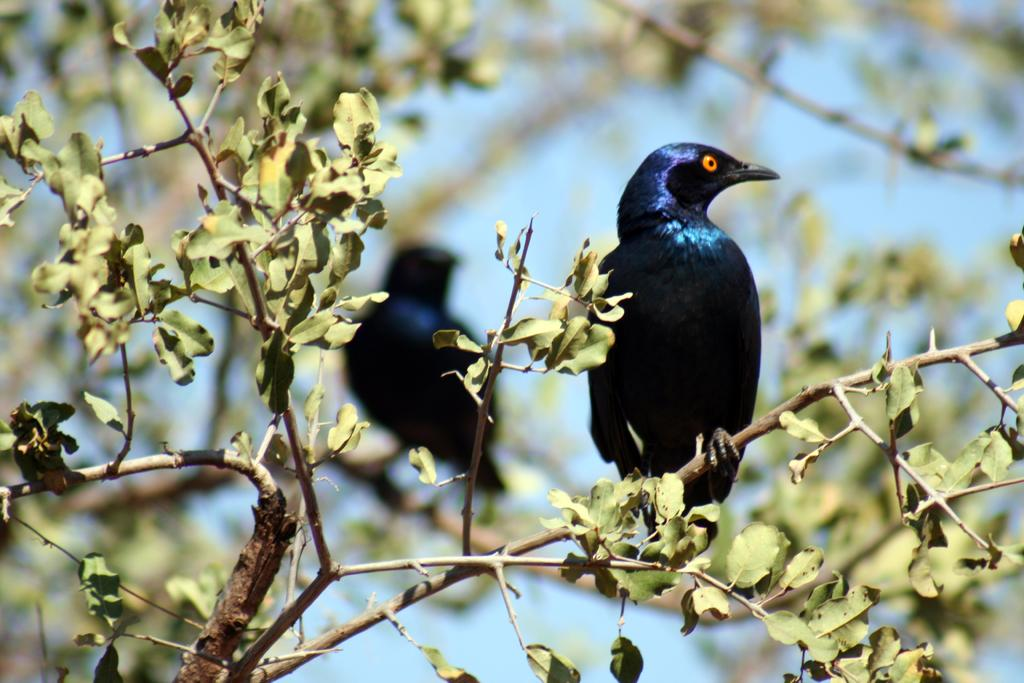What type of animals can be seen in the image? Birds can be seen in the image. Where are the birds located in the image? The birds are on a tree in the image. Can you describe the background of the image? The background of the image is blurred. What type of pump can be seen in the image? There is no pump present in the image. How many boys are visible in the image? There are no boys visible in the image. 